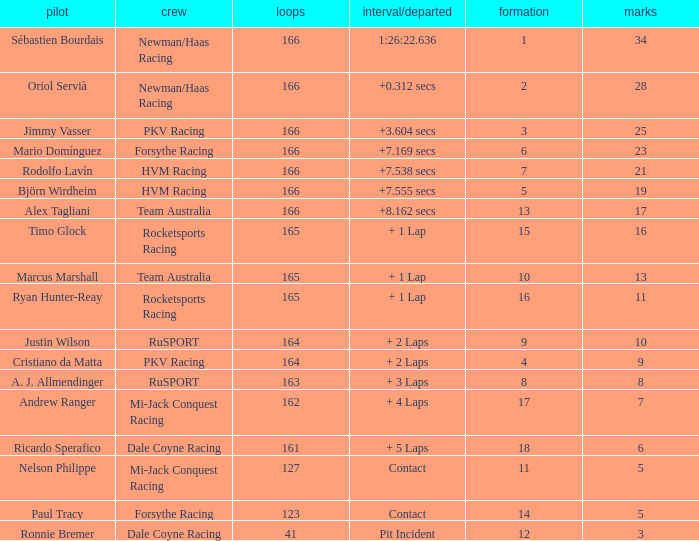What grid is the lowest when the time/retired is + 5 laps and the laps is less than 161? None. Give me the full table as a dictionary. {'header': ['pilot', 'crew', 'loops', 'interval/departed', 'formation', 'marks'], 'rows': [['Sébastien Bourdais', 'Newman/Haas Racing', '166', '1:26:22.636', '1', '34'], ['Oriol Servià', 'Newman/Haas Racing', '166', '+0.312 secs', '2', '28'], ['Jimmy Vasser', 'PKV Racing', '166', '+3.604 secs', '3', '25'], ['Mario Domínguez', 'Forsythe Racing', '166', '+7.169 secs', '6', '23'], ['Rodolfo Lavín', 'HVM Racing', '166', '+7.538 secs', '7', '21'], ['Björn Wirdheim', 'HVM Racing', '166', '+7.555 secs', '5', '19'], ['Alex Tagliani', 'Team Australia', '166', '+8.162 secs', '13', '17'], ['Timo Glock', 'Rocketsports Racing', '165', '+ 1 Lap', '15', '16'], ['Marcus Marshall', 'Team Australia', '165', '+ 1 Lap', '10', '13'], ['Ryan Hunter-Reay', 'Rocketsports Racing', '165', '+ 1 Lap', '16', '11'], ['Justin Wilson', 'RuSPORT', '164', '+ 2 Laps', '9', '10'], ['Cristiano da Matta', 'PKV Racing', '164', '+ 2 Laps', '4', '9'], ['A. J. Allmendinger', 'RuSPORT', '163', '+ 3 Laps', '8', '8'], ['Andrew Ranger', 'Mi-Jack Conquest Racing', '162', '+ 4 Laps', '17', '7'], ['Ricardo Sperafico', 'Dale Coyne Racing', '161', '+ 5 Laps', '18', '6'], ['Nelson Philippe', 'Mi-Jack Conquest Racing', '127', 'Contact', '11', '5'], ['Paul Tracy', 'Forsythe Racing', '123', 'Contact', '14', '5'], ['Ronnie Bremer', 'Dale Coyne Racing', '41', 'Pit Incident', '12', '3']]} 